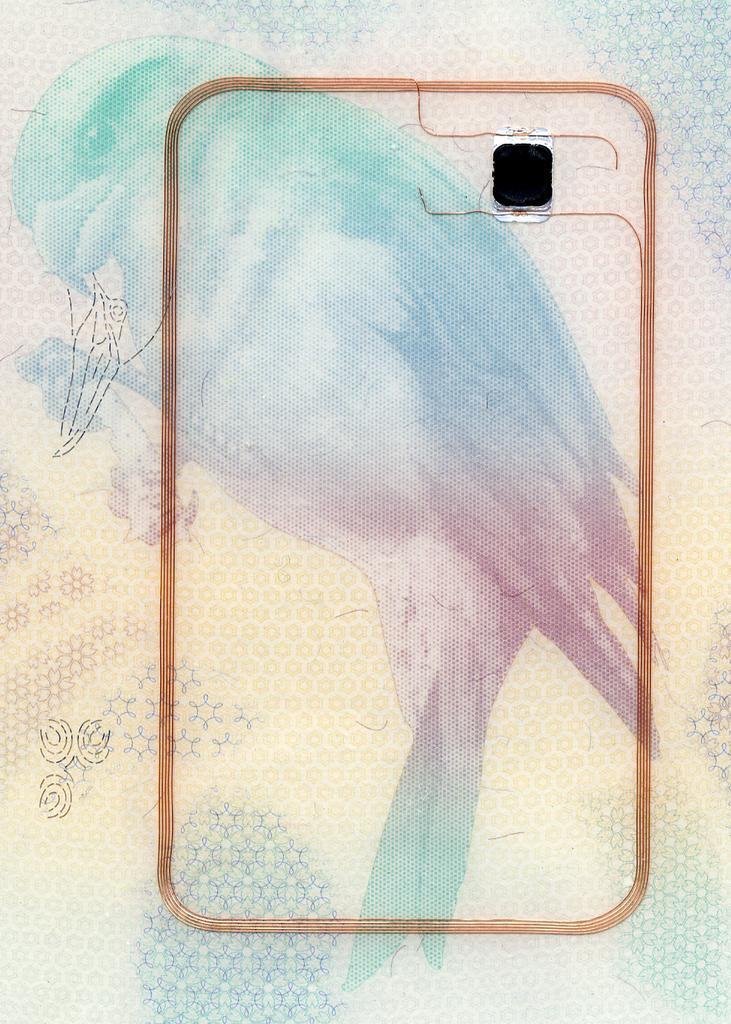Please provide a concise description of this image. In this image we can see a painting of a bird, also we can see a black colored spot. 